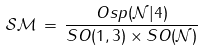Convert formula to latex. <formula><loc_0><loc_0><loc_500><loc_500>\mathcal { S M } \, = \, \frac { O s p ( \mathcal { N } | 4 ) } { S O ( 1 , 3 ) \times S O ( \mathcal { N } ) }</formula> 